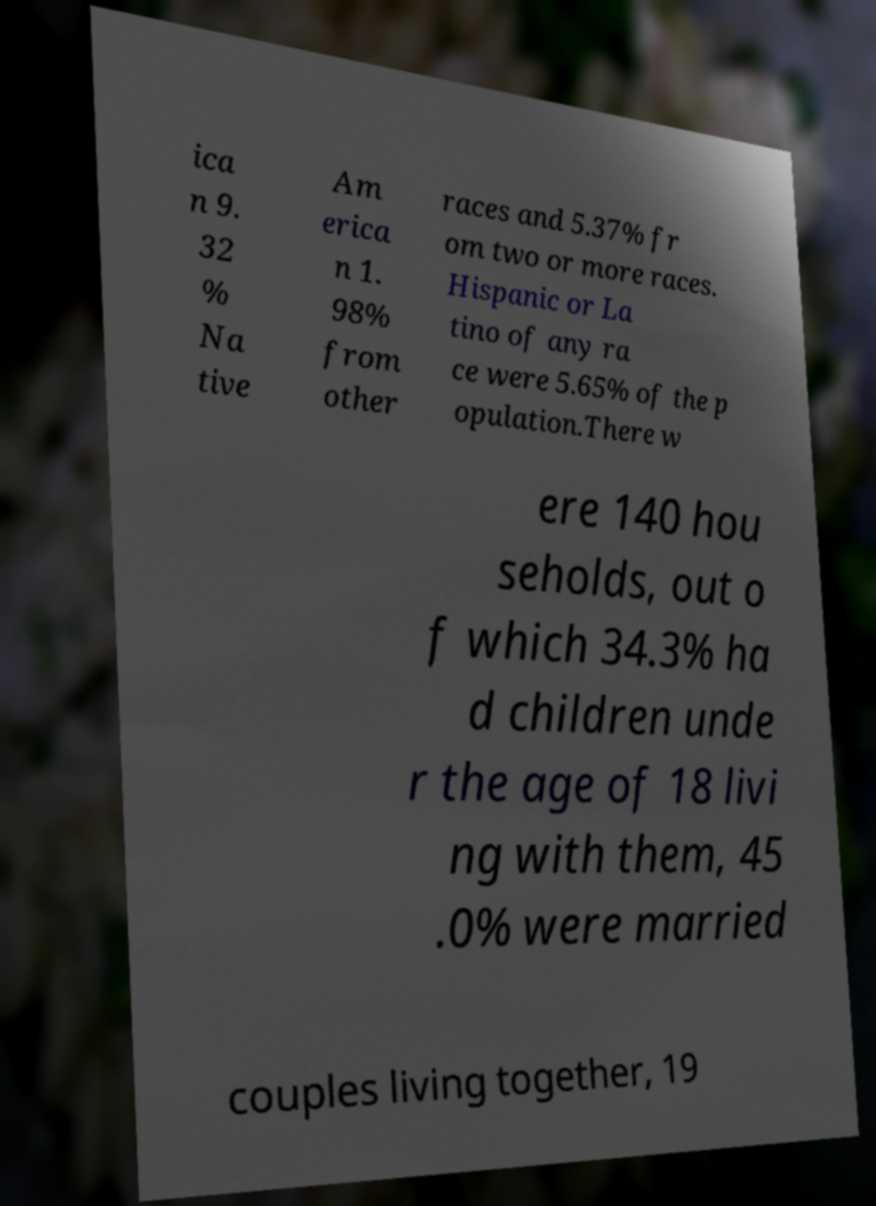Please identify and transcribe the text found in this image. ica n 9. 32 % Na tive Am erica n 1. 98% from other races and 5.37% fr om two or more races. Hispanic or La tino of any ra ce were 5.65% of the p opulation.There w ere 140 hou seholds, out o f which 34.3% ha d children unde r the age of 18 livi ng with them, 45 .0% were married couples living together, 19 